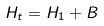Convert formula to latex. <formula><loc_0><loc_0><loc_500><loc_500>H _ { t } = H _ { 1 } + B</formula> 